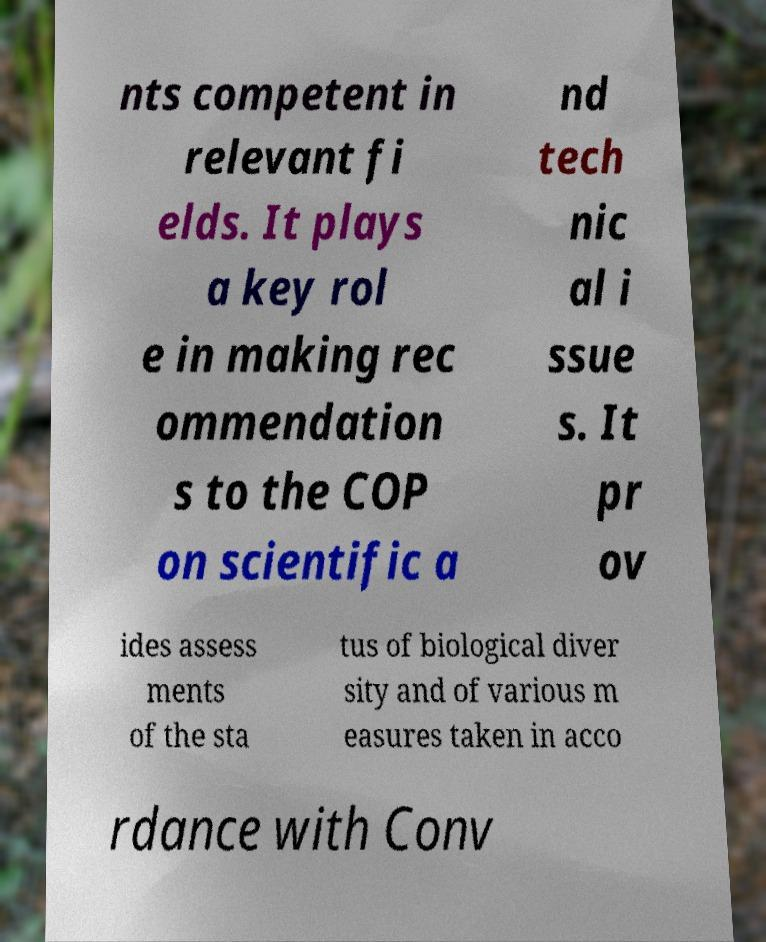Please read and relay the text visible in this image. What does it say? nts competent in relevant fi elds. It plays a key rol e in making rec ommendation s to the COP on scientific a nd tech nic al i ssue s. It pr ov ides assess ments of the sta tus of biological diver sity and of various m easures taken in acco rdance with Conv 